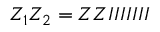Convert formula to latex. <formula><loc_0><loc_0><loc_500><loc_500>Z _ { 1 } Z _ { 2 } = Z Z I I I I I I I</formula> 